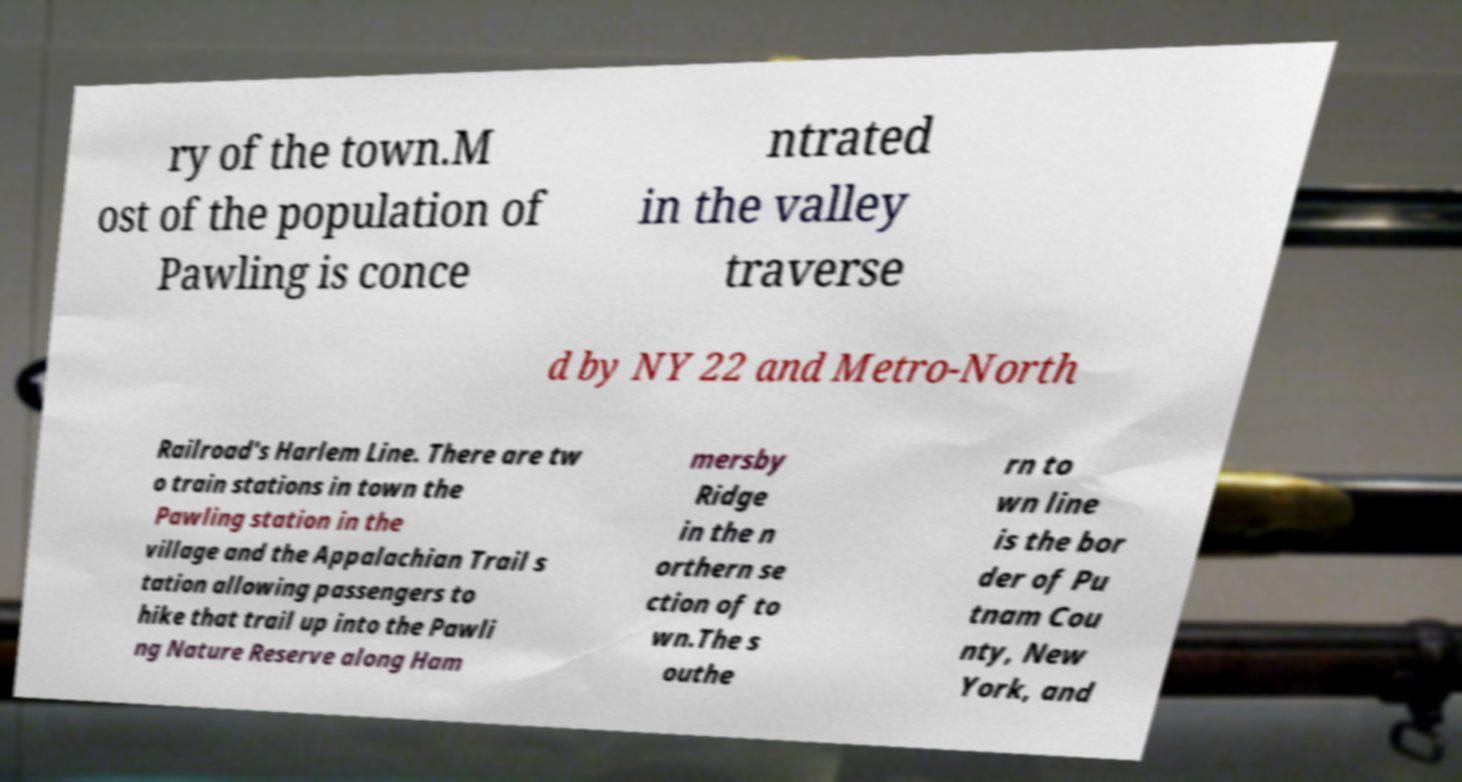There's text embedded in this image that I need extracted. Can you transcribe it verbatim? ry of the town.M ost of the population of Pawling is conce ntrated in the valley traverse d by NY 22 and Metro-North Railroad's Harlem Line. There are tw o train stations in town the Pawling station in the village and the Appalachian Trail s tation allowing passengers to hike that trail up into the Pawli ng Nature Reserve along Ham mersby Ridge in the n orthern se ction of to wn.The s outhe rn to wn line is the bor der of Pu tnam Cou nty, New York, and 